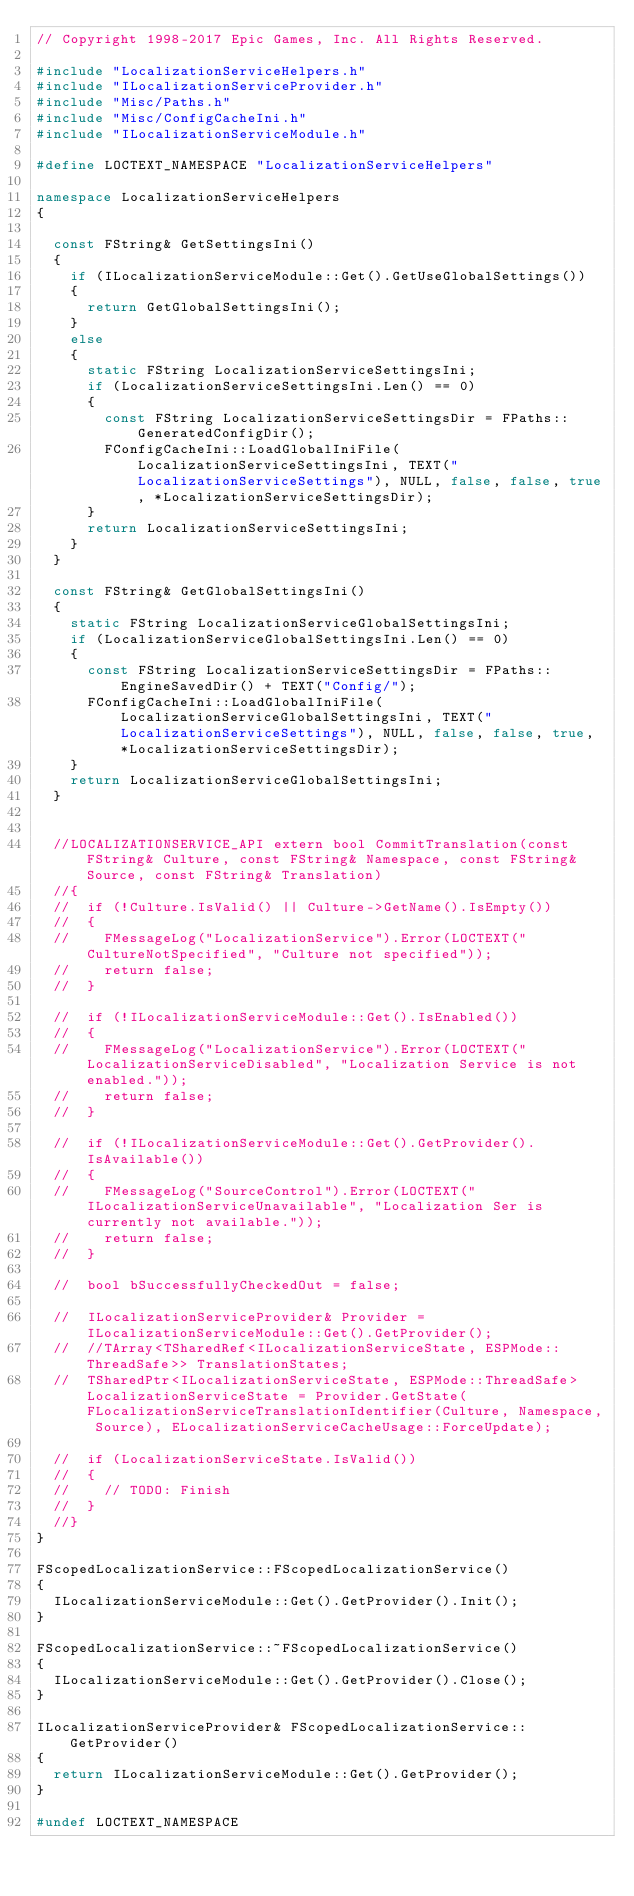Convert code to text. <code><loc_0><loc_0><loc_500><loc_500><_C++_>// Copyright 1998-2017 Epic Games, Inc. All Rights Reserved.

#include "LocalizationServiceHelpers.h"
#include "ILocalizationServiceProvider.h"
#include "Misc/Paths.h"
#include "Misc/ConfigCacheIni.h"
#include "ILocalizationServiceModule.h"

#define LOCTEXT_NAMESPACE "LocalizationServiceHelpers"

namespace LocalizationServiceHelpers
{

	const FString& GetSettingsIni()
	{
		if (ILocalizationServiceModule::Get().GetUseGlobalSettings())
		{
			return GetGlobalSettingsIni();
		}
		else
		{
			static FString LocalizationServiceSettingsIni;
			if (LocalizationServiceSettingsIni.Len() == 0)
			{
				const FString LocalizationServiceSettingsDir = FPaths::GeneratedConfigDir();
				FConfigCacheIni::LoadGlobalIniFile(LocalizationServiceSettingsIni, TEXT("LocalizationServiceSettings"), NULL, false, false, true, *LocalizationServiceSettingsDir);
			}
			return LocalizationServiceSettingsIni;
		}
	}

	const FString& GetGlobalSettingsIni()
	{
		static FString LocalizationServiceGlobalSettingsIni;
		if (LocalizationServiceGlobalSettingsIni.Len() == 0)
		{
			const FString LocalizationServiceSettingsDir = FPaths::EngineSavedDir() + TEXT("Config/");
			FConfigCacheIni::LoadGlobalIniFile(LocalizationServiceGlobalSettingsIni, TEXT("LocalizationServiceSettings"), NULL, false, false, true, *LocalizationServiceSettingsDir);
		}
		return LocalizationServiceGlobalSettingsIni;
	}


	//LOCALIZATIONSERVICE_API extern bool CommitTranslation(const FString& Culture, const FString& Namespace, const FString& Source, const FString& Translation)
	//{
	//	if (!Culture.IsValid() || Culture->GetName().IsEmpty())
	//	{
	//		FMessageLog("LocalizationService").Error(LOCTEXT("CultureNotSpecified", "Culture not specified"));
	//		return false;
	//	}

	//	if (!ILocalizationServiceModule::Get().IsEnabled())
	//	{
	//		FMessageLog("LocalizationService").Error(LOCTEXT("LocalizationServiceDisabled", "Localization Service is not enabled."));
	//		return false;
	//	}

	//	if (!ILocalizationServiceModule::Get().GetProvider().IsAvailable())
	//	{
	//		FMessageLog("SourceControl").Error(LOCTEXT("ILocalizationServiceUnavailable", "Localization Ser is currently not available."));
	//		return false;
	//	}

	//	bool bSuccessfullyCheckedOut = false;

	//	ILocalizationServiceProvider& Provider = ILocalizationServiceModule::Get().GetProvider();
	//	//TArray<TSharedRef<ILocalizationServiceState, ESPMode::ThreadSafe>> TranslationStates;
	//	TSharedPtr<ILocalizationServiceState, ESPMode::ThreadSafe> LocalizationServiceState = Provider.GetState(FLocalizationServiceTranslationIdentifier(Culture, Namespace, Source), ELocalizationServiceCacheUsage::ForceUpdate);

	//	if (LocalizationServiceState.IsValid())
	//	{
	//		// TODO: Finish
	//	}
	//}
}

FScopedLocalizationService::FScopedLocalizationService()
{
	ILocalizationServiceModule::Get().GetProvider().Init();
}

FScopedLocalizationService::~FScopedLocalizationService()
{
	ILocalizationServiceModule::Get().GetProvider().Close();
}

ILocalizationServiceProvider& FScopedLocalizationService::GetProvider()
{
	return ILocalizationServiceModule::Get().GetProvider();
}

#undef LOCTEXT_NAMESPACE
</code> 